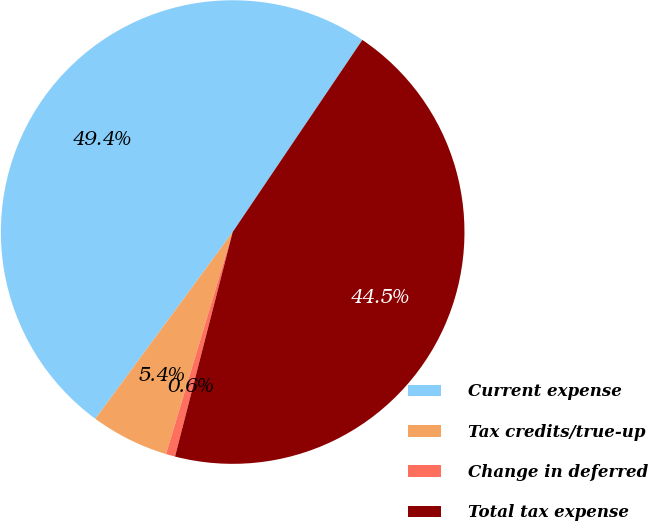Convert chart to OTSL. <chart><loc_0><loc_0><loc_500><loc_500><pie_chart><fcel>Current expense<fcel>Tax credits/true-up<fcel>Change in deferred<fcel>Total tax expense<nl><fcel>49.36%<fcel>5.45%<fcel>0.64%<fcel>44.55%<nl></chart> 